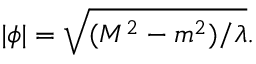<formula> <loc_0><loc_0><loc_500><loc_500>| \phi | = \sqrt { ( M ^ { 2 } - m ^ { 2 } ) / \lambda } .</formula> 